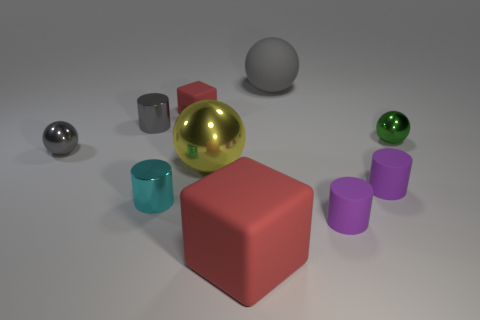Subtract all yellow cylinders. Subtract all blue cubes. How many cylinders are left? 4 Subtract all blocks. How many objects are left? 8 Add 1 large red rubber objects. How many large red rubber objects are left? 2 Add 8 tiny green things. How many tiny green things exist? 9 Subtract 0 brown spheres. How many objects are left? 10 Subtract all cylinders. Subtract all cyan cylinders. How many objects are left? 5 